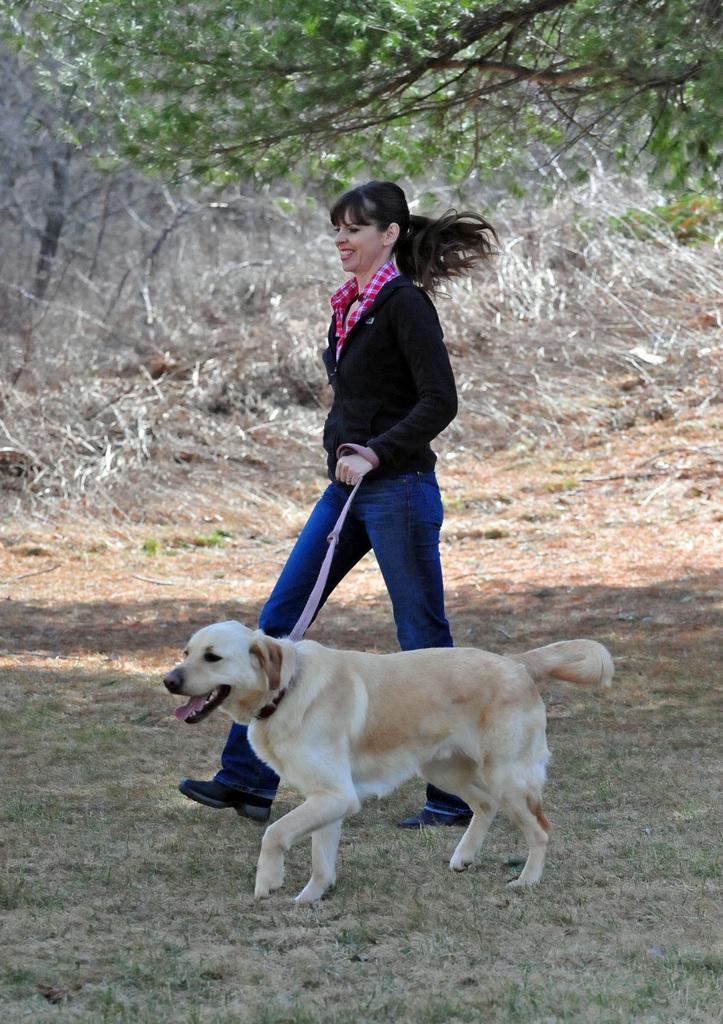How would you summarize this image in a sentence or two? in the picture a woman is walking by holding a belt of a dog which is walking beside,here there are many trees. 